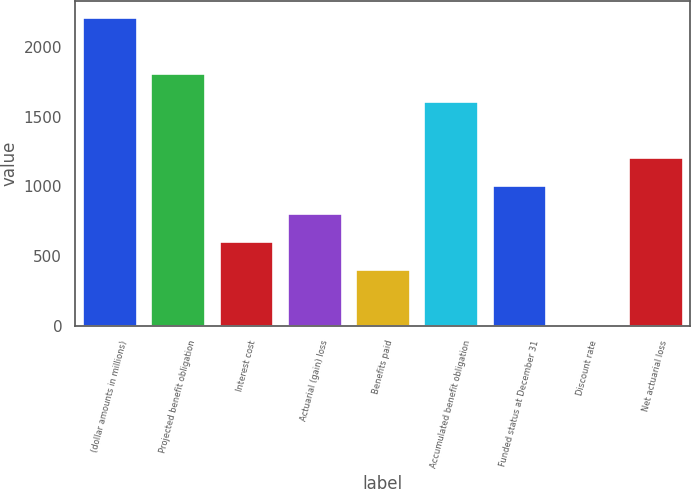<chart> <loc_0><loc_0><loc_500><loc_500><bar_chart><fcel>(dollar amounts in millions)<fcel>Projected benefit obligation<fcel>Interest cost<fcel>Actuarial (gain) loss<fcel>Benefits paid<fcel>Accumulated benefit obligation<fcel>Funded status at December 31<fcel>Discount rate<fcel>Net actuarial loss<nl><fcel>2213.75<fcel>1812.19<fcel>607.51<fcel>808.29<fcel>406.73<fcel>1611.41<fcel>1009.07<fcel>5.17<fcel>1209.85<nl></chart> 